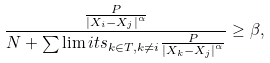Convert formula to latex. <formula><loc_0><loc_0><loc_500><loc_500>\frac { \frac { P } { { | X _ { i } - X _ { j } | } ^ { \alpha } } } { N + \sum \lim i t s _ { k \in T , k \neq i } \frac { P } { { | X _ { k } - X _ { j } | } ^ { \alpha } } } \geq \beta ,</formula> 